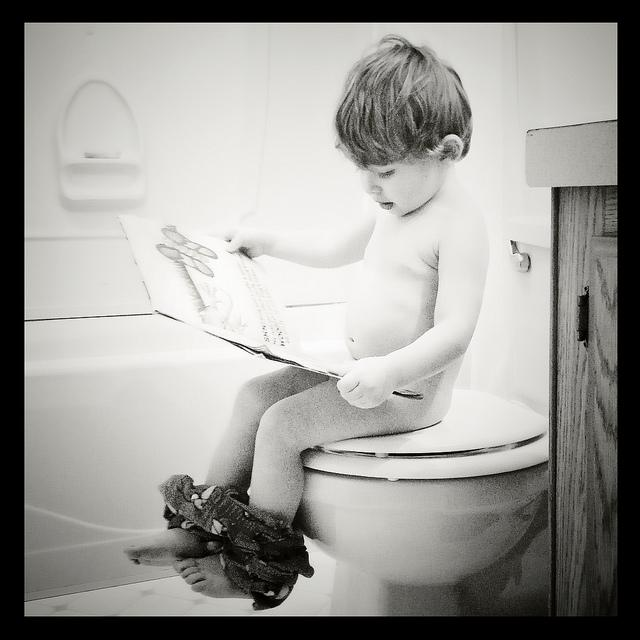What does the child do here?

Choices:
A) brush teeth
B) number 1
C) number 2
D) read read 